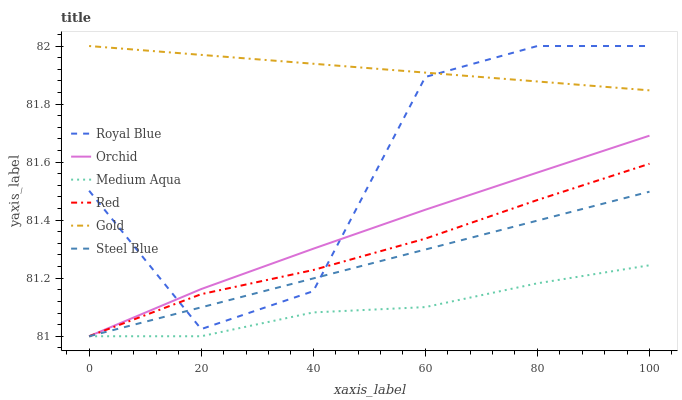Does Medium Aqua have the minimum area under the curve?
Answer yes or no. Yes. Does Gold have the maximum area under the curve?
Answer yes or no. Yes. Does Steel Blue have the minimum area under the curve?
Answer yes or no. No. Does Steel Blue have the maximum area under the curve?
Answer yes or no. No. Is Gold the smoothest?
Answer yes or no. Yes. Is Royal Blue the roughest?
Answer yes or no. Yes. Is Steel Blue the smoothest?
Answer yes or no. No. Is Steel Blue the roughest?
Answer yes or no. No. Does Royal Blue have the lowest value?
Answer yes or no. No. Does Royal Blue have the highest value?
Answer yes or no. Yes. Does Steel Blue have the highest value?
Answer yes or no. No. Is Medium Aqua less than Gold?
Answer yes or no. Yes. Is Gold greater than Orchid?
Answer yes or no. Yes. Does Steel Blue intersect Red?
Answer yes or no. Yes. Is Steel Blue less than Red?
Answer yes or no. No. Is Steel Blue greater than Red?
Answer yes or no. No. Does Medium Aqua intersect Gold?
Answer yes or no. No. 